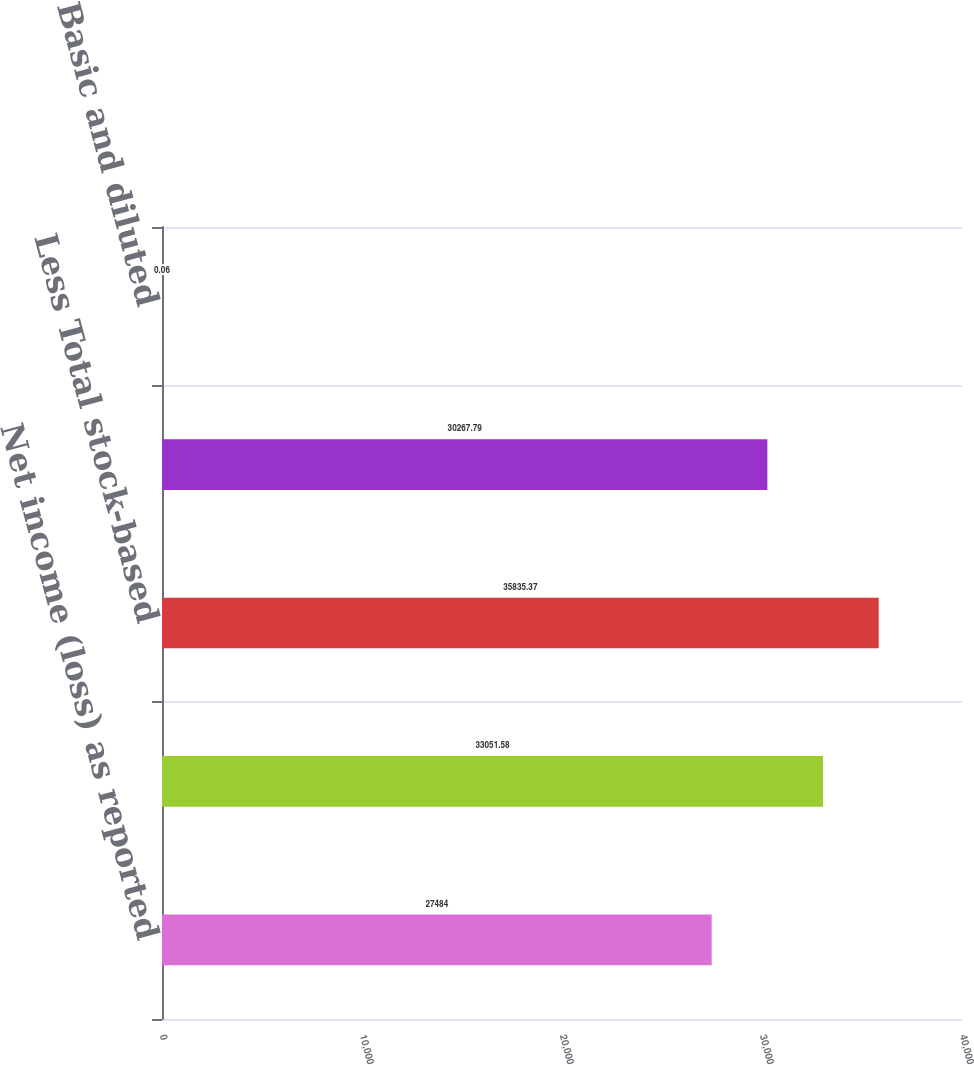Convert chart to OTSL. <chart><loc_0><loc_0><loc_500><loc_500><bar_chart><fcel>Net income (loss) as reported<fcel>Add Stock-based employee<fcel>Less Total stock-based<fcel>Pro-forma net income (loss)<fcel>Basic and diluted<nl><fcel>27484<fcel>33051.6<fcel>35835.4<fcel>30267.8<fcel>0.06<nl></chart> 